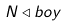<formula> <loc_0><loc_0><loc_500><loc_500>N \triangleleft { b o y }</formula> 